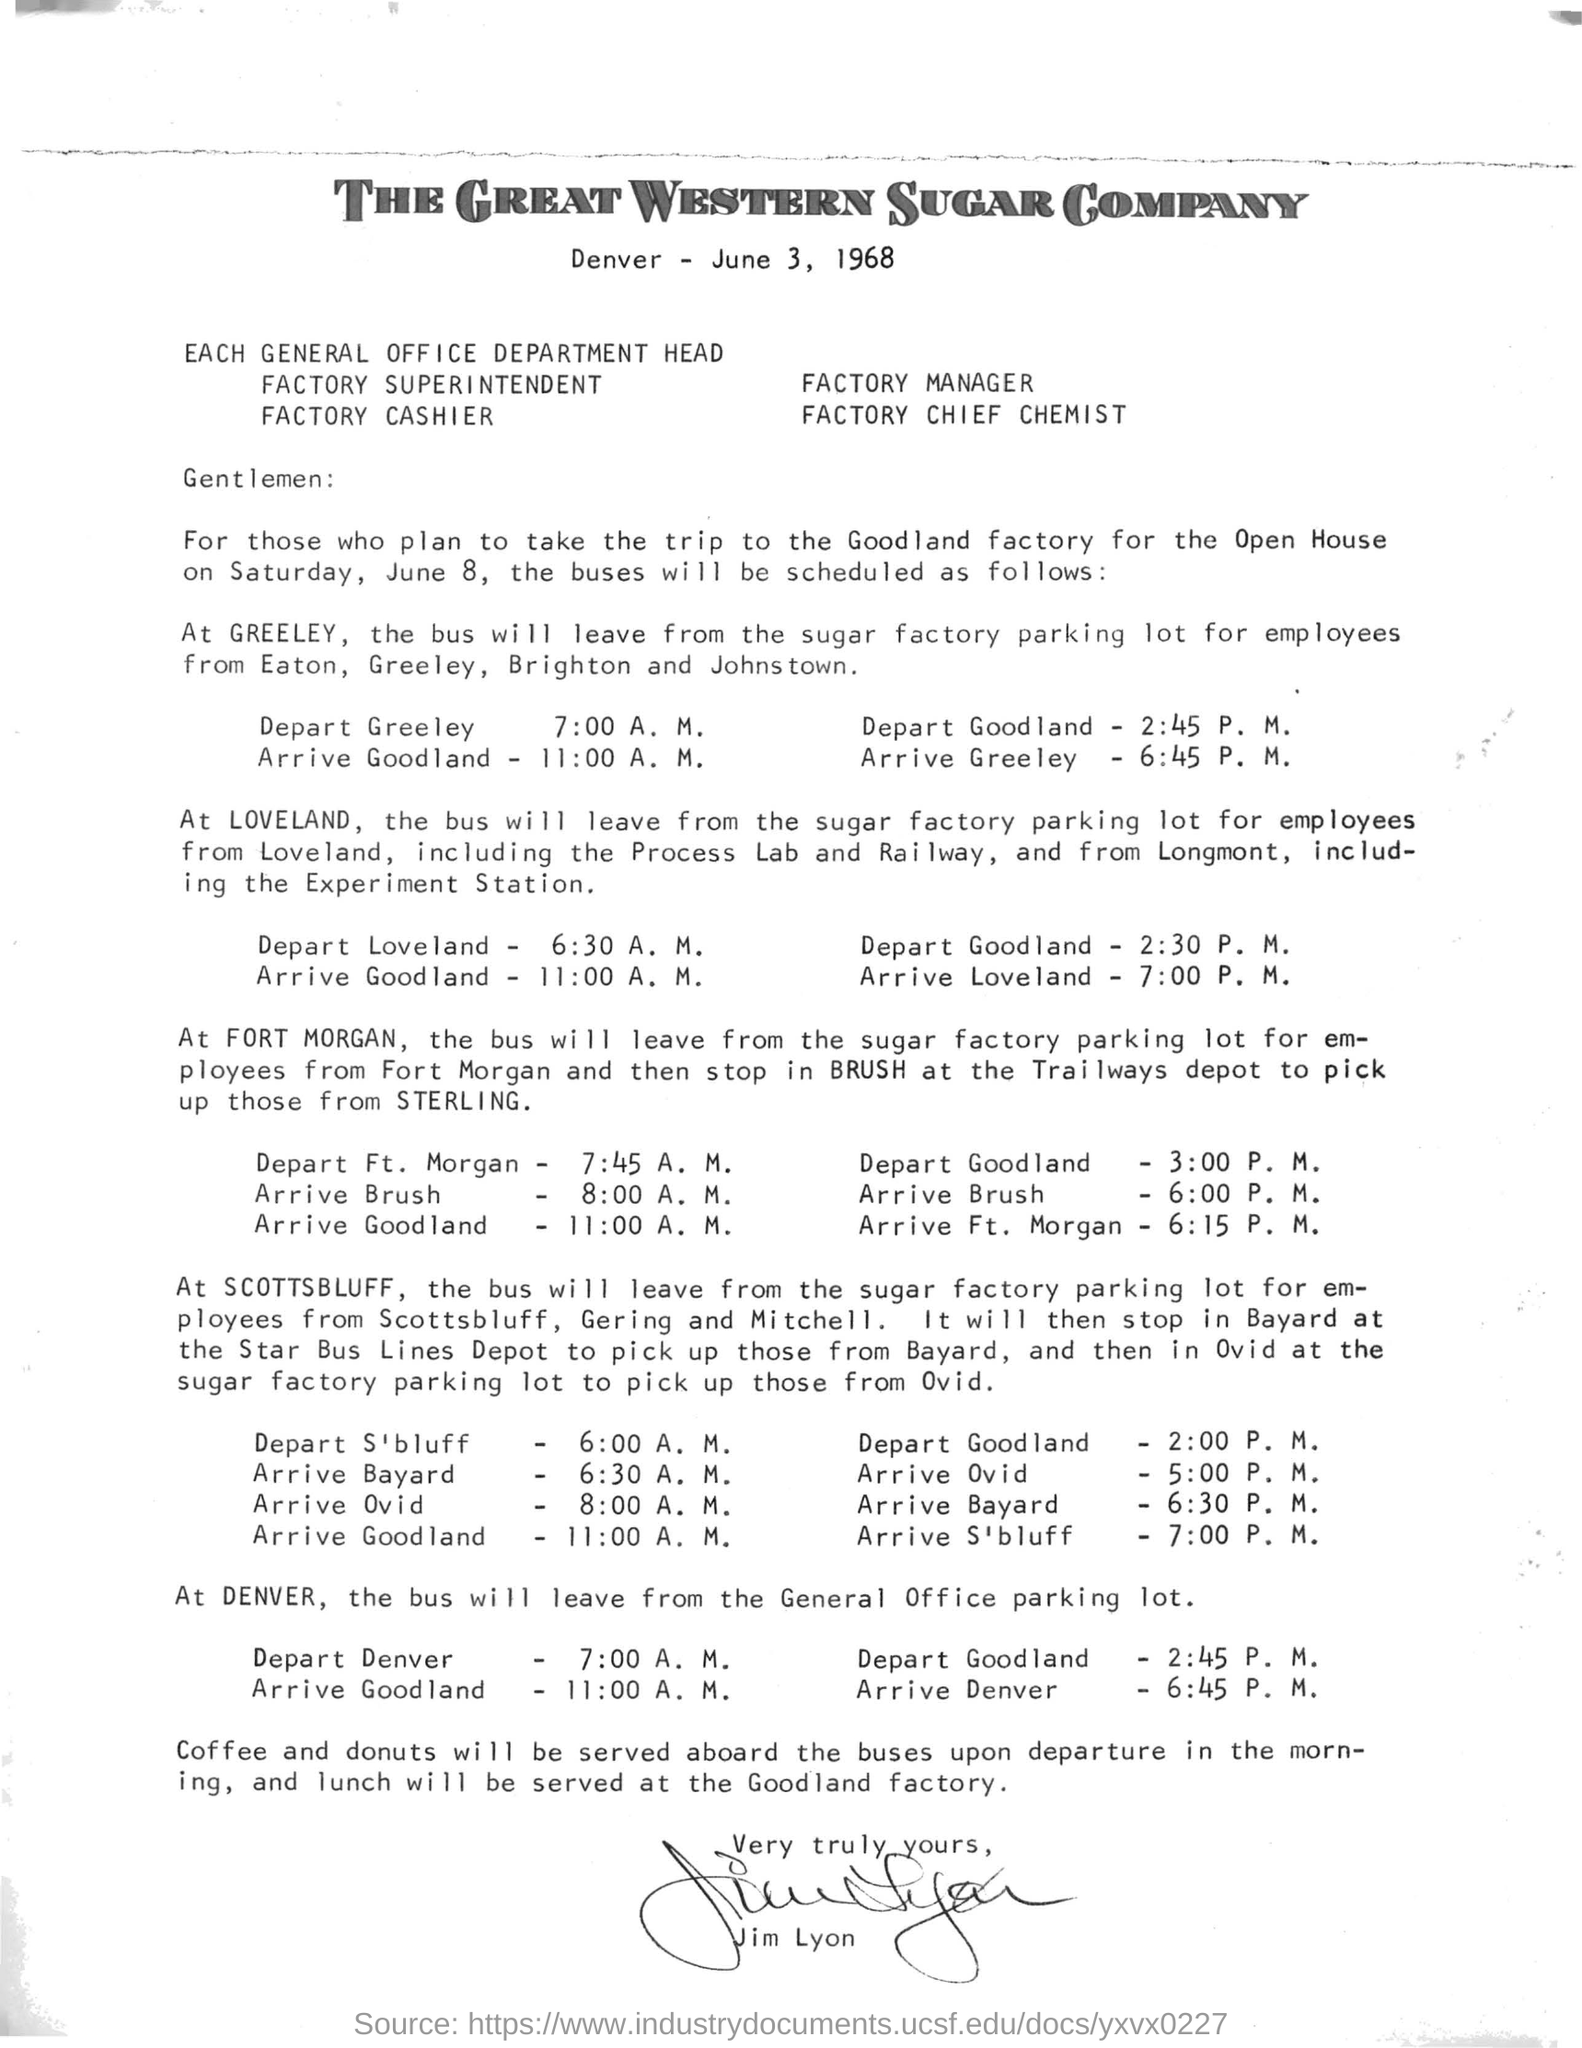Where does the bus leave from at Denver?
Give a very brief answer. General Office parking lot. Whan was the trip to the Goodland factory for the Open House?
Offer a very short reply. June 8. When is the letter dated on?
Your response must be concise. June 3, 1968. Who has signed the letter?
Your answer should be very brief. Jim Lyon. At what time will the bus to Loveland  from Goodland leave?
Keep it short and to the point. 2:30 P.M. What is the stop before Ft. Morgan?
Offer a very short reply. Brush. Which starting station is closest to Goodland factory, based on these bus schedules?
Give a very brief answer. Ft. Morgan. 